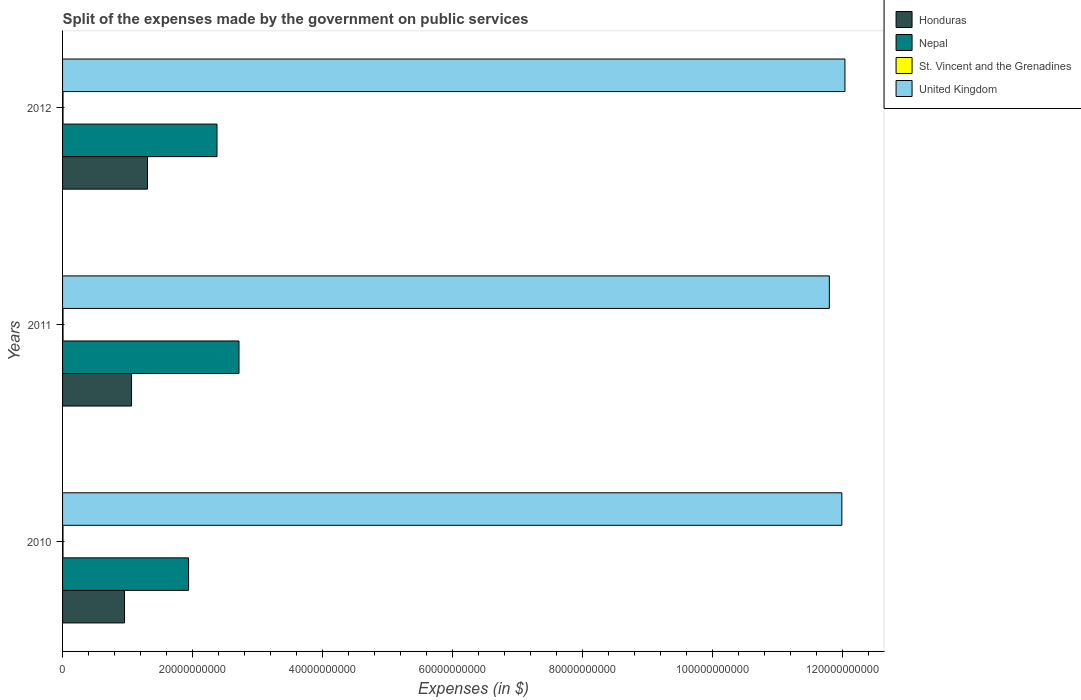How many different coloured bars are there?
Ensure brevity in your answer.  4. Are the number of bars per tick equal to the number of legend labels?
Keep it short and to the point. Yes. How many bars are there on the 3rd tick from the top?
Give a very brief answer. 4. How many bars are there on the 1st tick from the bottom?
Give a very brief answer. 4. What is the expenses made by the government on public services in United Kingdom in 2010?
Keep it short and to the point. 1.20e+11. Across all years, what is the maximum expenses made by the government on public services in Honduras?
Your answer should be very brief. 1.31e+1. Across all years, what is the minimum expenses made by the government on public services in Honduras?
Provide a short and direct response. 9.53e+09. In which year was the expenses made by the government on public services in Nepal maximum?
Provide a succinct answer. 2011. What is the total expenses made by the government on public services in Nepal in the graph?
Provide a short and direct response. 7.03e+1. What is the difference between the expenses made by the government on public services in Nepal in 2011 and that in 2012?
Make the answer very short. 3.38e+09. What is the difference between the expenses made by the government on public services in United Kingdom in 2010 and the expenses made by the government on public services in Honduras in 2012?
Provide a short and direct response. 1.07e+11. What is the average expenses made by the government on public services in United Kingdom per year?
Offer a very short reply. 1.19e+11. In the year 2011, what is the difference between the expenses made by the government on public services in St. Vincent and the Grenadines and expenses made by the government on public services in United Kingdom?
Offer a terse response. -1.18e+11. What is the ratio of the expenses made by the government on public services in United Kingdom in 2010 to that in 2012?
Provide a short and direct response. 1. What is the difference between the highest and the second highest expenses made by the government on public services in Nepal?
Your response must be concise. 3.38e+09. What is the difference between the highest and the lowest expenses made by the government on public services in St. Vincent and the Grenadines?
Make the answer very short. 7.20e+06. In how many years, is the expenses made by the government on public services in Nepal greater than the average expenses made by the government on public services in Nepal taken over all years?
Provide a short and direct response. 2. Is the sum of the expenses made by the government on public services in United Kingdom in 2010 and 2011 greater than the maximum expenses made by the government on public services in Honduras across all years?
Your answer should be very brief. Yes. What does the 2nd bar from the top in 2011 represents?
Your answer should be compact. St. Vincent and the Grenadines. What does the 2nd bar from the bottom in 2012 represents?
Make the answer very short. Nepal. What is the difference between two consecutive major ticks on the X-axis?
Give a very brief answer. 2.00e+1. How are the legend labels stacked?
Provide a short and direct response. Vertical. What is the title of the graph?
Ensure brevity in your answer.  Split of the expenses made by the government on public services. Does "Bermuda" appear as one of the legend labels in the graph?
Your answer should be very brief. No. What is the label or title of the X-axis?
Offer a terse response. Expenses (in $). What is the label or title of the Y-axis?
Provide a succinct answer. Years. What is the Expenses (in $) in Honduras in 2010?
Your answer should be compact. 9.53e+09. What is the Expenses (in $) of Nepal in 2010?
Your answer should be compact. 1.94e+1. What is the Expenses (in $) in St. Vincent and the Grenadines in 2010?
Offer a terse response. 6.71e+07. What is the Expenses (in $) in United Kingdom in 2010?
Offer a very short reply. 1.20e+11. What is the Expenses (in $) of Honduras in 2011?
Your answer should be very brief. 1.06e+1. What is the Expenses (in $) in Nepal in 2011?
Provide a succinct answer. 2.71e+1. What is the Expenses (in $) in St. Vincent and the Grenadines in 2011?
Provide a succinct answer. 7.43e+07. What is the Expenses (in $) in United Kingdom in 2011?
Provide a succinct answer. 1.18e+11. What is the Expenses (in $) in Honduras in 2012?
Your answer should be very brief. 1.31e+1. What is the Expenses (in $) of Nepal in 2012?
Your answer should be very brief. 2.38e+1. What is the Expenses (in $) of St. Vincent and the Grenadines in 2012?
Your answer should be compact. 7.05e+07. What is the Expenses (in $) in United Kingdom in 2012?
Make the answer very short. 1.20e+11. Across all years, what is the maximum Expenses (in $) in Honduras?
Provide a short and direct response. 1.31e+1. Across all years, what is the maximum Expenses (in $) of Nepal?
Your response must be concise. 2.71e+1. Across all years, what is the maximum Expenses (in $) of St. Vincent and the Grenadines?
Offer a terse response. 7.43e+07. Across all years, what is the maximum Expenses (in $) in United Kingdom?
Give a very brief answer. 1.20e+11. Across all years, what is the minimum Expenses (in $) in Honduras?
Keep it short and to the point. 9.53e+09. Across all years, what is the minimum Expenses (in $) in Nepal?
Your answer should be very brief. 1.94e+1. Across all years, what is the minimum Expenses (in $) of St. Vincent and the Grenadines?
Offer a very short reply. 6.71e+07. Across all years, what is the minimum Expenses (in $) of United Kingdom?
Offer a terse response. 1.18e+11. What is the total Expenses (in $) of Honduras in the graph?
Your answer should be compact. 3.32e+1. What is the total Expenses (in $) of Nepal in the graph?
Ensure brevity in your answer.  7.03e+1. What is the total Expenses (in $) of St. Vincent and the Grenadines in the graph?
Your answer should be compact. 2.12e+08. What is the total Expenses (in $) in United Kingdom in the graph?
Offer a terse response. 3.58e+11. What is the difference between the Expenses (in $) of Honduras in 2010 and that in 2011?
Your answer should be very brief. -1.08e+09. What is the difference between the Expenses (in $) in Nepal in 2010 and that in 2011?
Provide a succinct answer. -7.75e+09. What is the difference between the Expenses (in $) in St. Vincent and the Grenadines in 2010 and that in 2011?
Your answer should be very brief. -7.20e+06. What is the difference between the Expenses (in $) in United Kingdom in 2010 and that in 2011?
Offer a terse response. 1.92e+09. What is the difference between the Expenses (in $) in Honduras in 2010 and that in 2012?
Give a very brief answer. -3.53e+09. What is the difference between the Expenses (in $) in Nepal in 2010 and that in 2012?
Your answer should be compact. -4.37e+09. What is the difference between the Expenses (in $) in St. Vincent and the Grenadines in 2010 and that in 2012?
Your response must be concise. -3.40e+06. What is the difference between the Expenses (in $) in United Kingdom in 2010 and that in 2012?
Provide a short and direct response. -4.76e+08. What is the difference between the Expenses (in $) of Honduras in 2011 and that in 2012?
Give a very brief answer. -2.45e+09. What is the difference between the Expenses (in $) in Nepal in 2011 and that in 2012?
Make the answer very short. 3.38e+09. What is the difference between the Expenses (in $) in St. Vincent and the Grenadines in 2011 and that in 2012?
Your answer should be compact. 3.80e+06. What is the difference between the Expenses (in $) of United Kingdom in 2011 and that in 2012?
Keep it short and to the point. -2.40e+09. What is the difference between the Expenses (in $) of Honduras in 2010 and the Expenses (in $) of Nepal in 2011?
Provide a short and direct response. -1.76e+1. What is the difference between the Expenses (in $) in Honduras in 2010 and the Expenses (in $) in St. Vincent and the Grenadines in 2011?
Your response must be concise. 9.46e+09. What is the difference between the Expenses (in $) of Honduras in 2010 and the Expenses (in $) of United Kingdom in 2011?
Provide a short and direct response. -1.08e+11. What is the difference between the Expenses (in $) in Nepal in 2010 and the Expenses (in $) in St. Vincent and the Grenadines in 2011?
Ensure brevity in your answer.  1.93e+1. What is the difference between the Expenses (in $) in Nepal in 2010 and the Expenses (in $) in United Kingdom in 2011?
Provide a succinct answer. -9.85e+1. What is the difference between the Expenses (in $) of St. Vincent and the Grenadines in 2010 and the Expenses (in $) of United Kingdom in 2011?
Offer a very short reply. -1.18e+11. What is the difference between the Expenses (in $) in Honduras in 2010 and the Expenses (in $) in Nepal in 2012?
Your answer should be very brief. -1.42e+1. What is the difference between the Expenses (in $) of Honduras in 2010 and the Expenses (in $) of St. Vincent and the Grenadines in 2012?
Make the answer very short. 9.46e+09. What is the difference between the Expenses (in $) in Honduras in 2010 and the Expenses (in $) in United Kingdom in 2012?
Your response must be concise. -1.11e+11. What is the difference between the Expenses (in $) in Nepal in 2010 and the Expenses (in $) in St. Vincent and the Grenadines in 2012?
Your answer should be very brief. 1.93e+1. What is the difference between the Expenses (in $) in Nepal in 2010 and the Expenses (in $) in United Kingdom in 2012?
Your answer should be very brief. -1.01e+11. What is the difference between the Expenses (in $) of St. Vincent and the Grenadines in 2010 and the Expenses (in $) of United Kingdom in 2012?
Your answer should be compact. -1.20e+11. What is the difference between the Expenses (in $) in Honduras in 2011 and the Expenses (in $) in Nepal in 2012?
Keep it short and to the point. -1.31e+1. What is the difference between the Expenses (in $) in Honduras in 2011 and the Expenses (in $) in St. Vincent and the Grenadines in 2012?
Offer a very short reply. 1.05e+1. What is the difference between the Expenses (in $) in Honduras in 2011 and the Expenses (in $) in United Kingdom in 2012?
Offer a terse response. -1.10e+11. What is the difference between the Expenses (in $) of Nepal in 2011 and the Expenses (in $) of St. Vincent and the Grenadines in 2012?
Make the answer very short. 2.71e+1. What is the difference between the Expenses (in $) of Nepal in 2011 and the Expenses (in $) of United Kingdom in 2012?
Provide a short and direct response. -9.32e+1. What is the difference between the Expenses (in $) in St. Vincent and the Grenadines in 2011 and the Expenses (in $) in United Kingdom in 2012?
Provide a short and direct response. -1.20e+11. What is the average Expenses (in $) in Honduras per year?
Your response must be concise. 1.11e+1. What is the average Expenses (in $) of Nepal per year?
Your answer should be very brief. 2.34e+1. What is the average Expenses (in $) of St. Vincent and the Grenadines per year?
Your answer should be very brief. 7.06e+07. What is the average Expenses (in $) in United Kingdom per year?
Offer a terse response. 1.19e+11. In the year 2010, what is the difference between the Expenses (in $) of Honduras and Expenses (in $) of Nepal?
Make the answer very short. -9.85e+09. In the year 2010, what is the difference between the Expenses (in $) in Honduras and Expenses (in $) in St. Vincent and the Grenadines?
Offer a terse response. 9.46e+09. In the year 2010, what is the difference between the Expenses (in $) of Honduras and Expenses (in $) of United Kingdom?
Your answer should be compact. -1.10e+11. In the year 2010, what is the difference between the Expenses (in $) of Nepal and Expenses (in $) of St. Vincent and the Grenadines?
Your response must be concise. 1.93e+1. In the year 2010, what is the difference between the Expenses (in $) of Nepal and Expenses (in $) of United Kingdom?
Ensure brevity in your answer.  -1.00e+11. In the year 2010, what is the difference between the Expenses (in $) in St. Vincent and the Grenadines and Expenses (in $) in United Kingdom?
Offer a terse response. -1.20e+11. In the year 2011, what is the difference between the Expenses (in $) of Honduras and Expenses (in $) of Nepal?
Keep it short and to the point. -1.65e+1. In the year 2011, what is the difference between the Expenses (in $) in Honduras and Expenses (in $) in St. Vincent and the Grenadines?
Offer a very short reply. 1.05e+1. In the year 2011, what is the difference between the Expenses (in $) in Honduras and Expenses (in $) in United Kingdom?
Keep it short and to the point. -1.07e+11. In the year 2011, what is the difference between the Expenses (in $) of Nepal and Expenses (in $) of St. Vincent and the Grenadines?
Offer a terse response. 2.71e+1. In the year 2011, what is the difference between the Expenses (in $) in Nepal and Expenses (in $) in United Kingdom?
Ensure brevity in your answer.  -9.08e+1. In the year 2011, what is the difference between the Expenses (in $) in St. Vincent and the Grenadines and Expenses (in $) in United Kingdom?
Make the answer very short. -1.18e+11. In the year 2012, what is the difference between the Expenses (in $) of Honduras and Expenses (in $) of Nepal?
Offer a terse response. -1.07e+1. In the year 2012, what is the difference between the Expenses (in $) in Honduras and Expenses (in $) in St. Vincent and the Grenadines?
Your response must be concise. 1.30e+1. In the year 2012, what is the difference between the Expenses (in $) in Honduras and Expenses (in $) in United Kingdom?
Ensure brevity in your answer.  -1.07e+11. In the year 2012, what is the difference between the Expenses (in $) of Nepal and Expenses (in $) of St. Vincent and the Grenadines?
Your response must be concise. 2.37e+1. In the year 2012, what is the difference between the Expenses (in $) in Nepal and Expenses (in $) in United Kingdom?
Ensure brevity in your answer.  -9.66e+1. In the year 2012, what is the difference between the Expenses (in $) of St. Vincent and the Grenadines and Expenses (in $) of United Kingdom?
Your response must be concise. -1.20e+11. What is the ratio of the Expenses (in $) of Honduras in 2010 to that in 2011?
Provide a succinct answer. 0.9. What is the ratio of the Expenses (in $) of St. Vincent and the Grenadines in 2010 to that in 2011?
Provide a short and direct response. 0.9. What is the ratio of the Expenses (in $) in United Kingdom in 2010 to that in 2011?
Give a very brief answer. 1.02. What is the ratio of the Expenses (in $) of Honduras in 2010 to that in 2012?
Make the answer very short. 0.73. What is the ratio of the Expenses (in $) of Nepal in 2010 to that in 2012?
Make the answer very short. 0.82. What is the ratio of the Expenses (in $) in St. Vincent and the Grenadines in 2010 to that in 2012?
Provide a succinct answer. 0.95. What is the ratio of the Expenses (in $) in United Kingdom in 2010 to that in 2012?
Provide a succinct answer. 1. What is the ratio of the Expenses (in $) in Honduras in 2011 to that in 2012?
Keep it short and to the point. 0.81. What is the ratio of the Expenses (in $) in Nepal in 2011 to that in 2012?
Give a very brief answer. 1.14. What is the ratio of the Expenses (in $) in St. Vincent and the Grenadines in 2011 to that in 2012?
Provide a short and direct response. 1.05. What is the ratio of the Expenses (in $) in United Kingdom in 2011 to that in 2012?
Offer a very short reply. 0.98. What is the difference between the highest and the second highest Expenses (in $) in Honduras?
Ensure brevity in your answer.  2.45e+09. What is the difference between the highest and the second highest Expenses (in $) in Nepal?
Offer a terse response. 3.38e+09. What is the difference between the highest and the second highest Expenses (in $) of St. Vincent and the Grenadines?
Give a very brief answer. 3.80e+06. What is the difference between the highest and the second highest Expenses (in $) in United Kingdom?
Ensure brevity in your answer.  4.76e+08. What is the difference between the highest and the lowest Expenses (in $) of Honduras?
Ensure brevity in your answer.  3.53e+09. What is the difference between the highest and the lowest Expenses (in $) in Nepal?
Offer a very short reply. 7.75e+09. What is the difference between the highest and the lowest Expenses (in $) of St. Vincent and the Grenadines?
Make the answer very short. 7.20e+06. What is the difference between the highest and the lowest Expenses (in $) of United Kingdom?
Your response must be concise. 2.40e+09. 